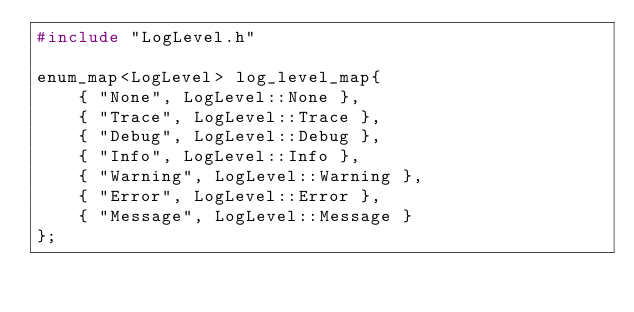Convert code to text. <code><loc_0><loc_0><loc_500><loc_500><_C++_>#include "LogLevel.h"

enum_map<LogLevel> log_level_map{
    { "None", LogLevel::None },
    { "Trace", LogLevel::Trace },
    { "Debug", LogLevel::Debug },
    { "Info", LogLevel::Info },
    { "Warning", LogLevel::Warning },
    { "Error", LogLevel::Error },
    { "Message", LogLevel::Message }
};
</code> 